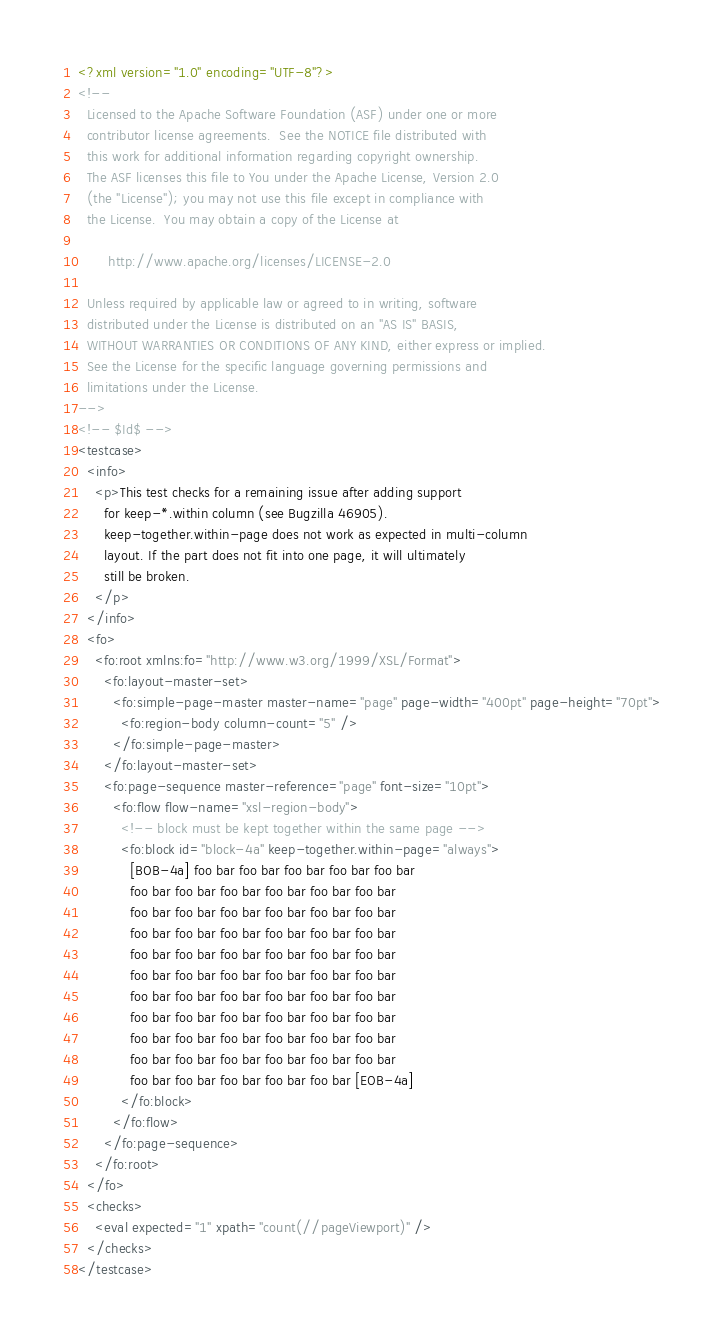<code> <loc_0><loc_0><loc_500><loc_500><_XML_><?xml version="1.0" encoding="UTF-8"?>
<!--
  Licensed to the Apache Software Foundation (ASF) under one or more
  contributor license agreements.  See the NOTICE file distributed with
  this work for additional information regarding copyright ownership.
  The ASF licenses this file to You under the Apache License, Version 2.0
  (the "License"); you may not use this file except in compliance with
  the License.  You may obtain a copy of the License at

       http://www.apache.org/licenses/LICENSE-2.0

  Unless required by applicable law or agreed to in writing, software
  distributed under the License is distributed on an "AS IS" BASIS,
  WITHOUT WARRANTIES OR CONDITIONS OF ANY KIND, either express or implied.
  See the License for the specific language governing permissions and
  limitations under the License.
-->
<!-- $Id$ -->
<testcase>
  <info>
    <p>This test checks for a remaining issue after adding support
      for keep-*.within column (see Bugzilla 46905). 
      keep-together.within-page does not work as expected in multi-column
      layout. If the part does not fit into one page, it will ultimately
      still be broken.
    </p>
  </info>
  <fo>
    <fo:root xmlns:fo="http://www.w3.org/1999/XSL/Format">
      <fo:layout-master-set>
        <fo:simple-page-master master-name="page" page-width="400pt" page-height="70pt">
          <fo:region-body column-count="5" />
        </fo:simple-page-master>
      </fo:layout-master-set>
      <fo:page-sequence master-reference="page" font-size="10pt">
        <fo:flow flow-name="xsl-region-body">
          <!-- block must be kept together within the same page -->
          <fo:block id="block-4a" keep-together.within-page="always">
            [BOB-4a] foo bar foo bar foo bar foo bar foo bar
            foo bar foo bar foo bar foo bar foo bar foo bar
            foo bar foo bar foo bar foo bar foo bar foo bar
            foo bar foo bar foo bar foo bar foo bar foo bar
            foo bar foo bar foo bar foo bar foo bar foo bar
            foo bar foo bar foo bar foo bar foo bar foo bar
            foo bar foo bar foo bar foo bar foo bar foo bar
            foo bar foo bar foo bar foo bar foo bar foo bar
            foo bar foo bar foo bar foo bar foo bar foo bar
            foo bar foo bar foo bar foo bar foo bar foo bar
            foo bar foo bar foo bar foo bar foo bar [EOB-4a]
          </fo:block>
        </fo:flow>
      </fo:page-sequence>
    </fo:root>
  </fo>
  <checks>
    <eval expected="1" xpath="count(//pageViewport)" />
  </checks>
</testcase>
</code> 